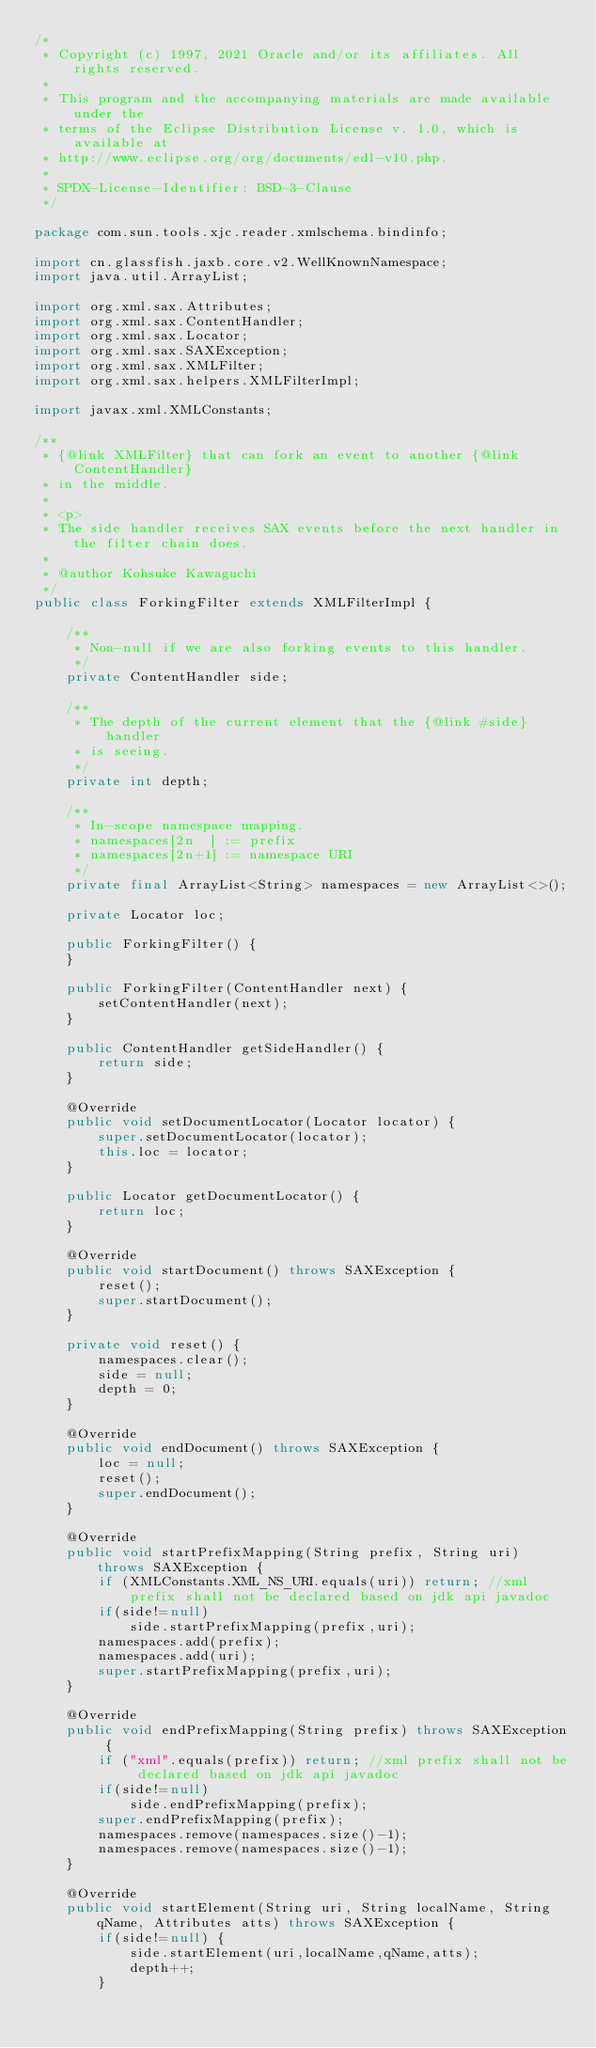<code> <loc_0><loc_0><loc_500><loc_500><_Java_>/*
 * Copyright (c) 1997, 2021 Oracle and/or its affiliates. All rights reserved.
 *
 * This program and the accompanying materials are made available under the
 * terms of the Eclipse Distribution License v. 1.0, which is available at
 * http://www.eclipse.org/org/documents/edl-v10.php.
 *
 * SPDX-License-Identifier: BSD-3-Clause
 */

package com.sun.tools.xjc.reader.xmlschema.bindinfo;

import cn.glassfish.jaxb.core.v2.WellKnownNamespace;
import java.util.ArrayList;

import org.xml.sax.Attributes;
import org.xml.sax.ContentHandler;
import org.xml.sax.Locator;
import org.xml.sax.SAXException;
import org.xml.sax.XMLFilter;
import org.xml.sax.helpers.XMLFilterImpl;

import javax.xml.XMLConstants;

/**
 * {@link XMLFilter} that can fork an event to another {@link ContentHandler}
 * in the middle.
 *
 * <p>
 * The side handler receives SAX events before the next handler in the filter chain does.
 *
 * @author Kohsuke Kawaguchi
 */
public class ForkingFilter extends XMLFilterImpl {

    /**
     * Non-null if we are also forking events to this handler.
     */
    private ContentHandler side;

    /**
     * The depth of the current element that the {@link #side} handler
     * is seeing.
     */
    private int depth;

    /**
     * In-scope namespace mapping.
     * namespaces[2n  ] := prefix
     * namespaces[2n+1] := namespace URI
     */
    private final ArrayList<String> namespaces = new ArrayList<>();

    private Locator loc;

    public ForkingFilter() {
    }

    public ForkingFilter(ContentHandler next) {
        setContentHandler(next);
    }

    public ContentHandler getSideHandler() {
        return side;
    }

    @Override
    public void setDocumentLocator(Locator locator) {
        super.setDocumentLocator(locator);
        this.loc = locator;
    }

    public Locator getDocumentLocator() {
        return loc;
    }

    @Override
    public void startDocument() throws SAXException {
        reset();
        super.startDocument();
    }

    private void reset() {
        namespaces.clear();
        side = null;
        depth = 0;
    }

    @Override
    public void endDocument() throws SAXException {
        loc = null;
        reset();
        super.endDocument();
    }

    @Override
    public void startPrefixMapping(String prefix, String uri) throws SAXException {
        if (XMLConstants.XML_NS_URI.equals(uri)) return; //xml prefix shall not be declared based on jdk api javadoc
        if(side!=null)
            side.startPrefixMapping(prefix,uri);
        namespaces.add(prefix);
        namespaces.add(uri);
        super.startPrefixMapping(prefix,uri);
    }

    @Override
    public void endPrefixMapping(String prefix) throws SAXException {
        if ("xml".equals(prefix)) return; //xml prefix shall not be declared based on jdk api javadoc
        if(side!=null)
            side.endPrefixMapping(prefix);
        super.endPrefixMapping(prefix);
        namespaces.remove(namespaces.size()-1);
        namespaces.remove(namespaces.size()-1);
    }

    @Override
    public void startElement(String uri, String localName, String qName, Attributes atts) throws SAXException {
        if(side!=null) {
            side.startElement(uri,localName,qName,atts);
            depth++;
        }</code> 